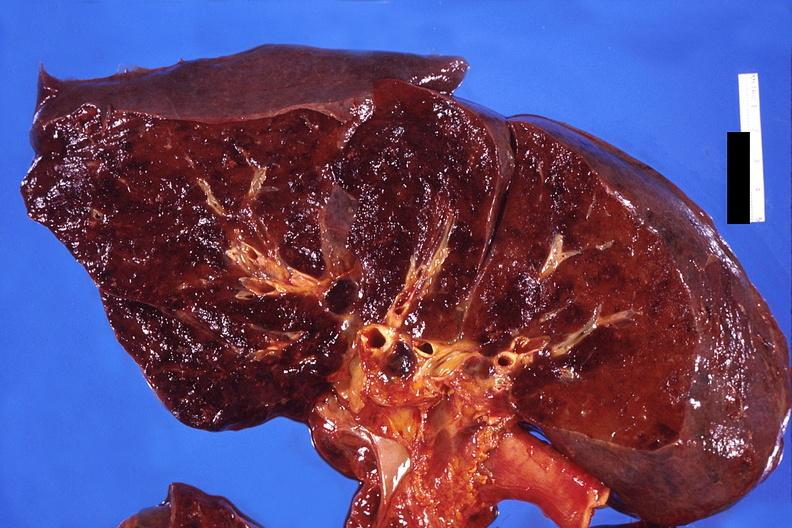what does this image show?
Answer the question using a single word or phrase. Lung 